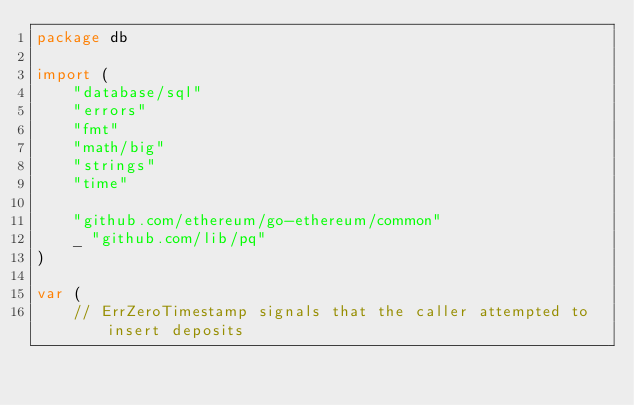Convert code to text. <code><loc_0><loc_0><loc_500><loc_500><_Go_>package db

import (
	"database/sql"
	"errors"
	"fmt"
	"math/big"
	"strings"
	"time"

	"github.com/ethereum/go-ethereum/common"
	_ "github.com/lib/pq"
)

var (
	// ErrZeroTimestamp signals that the caller attempted to insert deposits</code> 